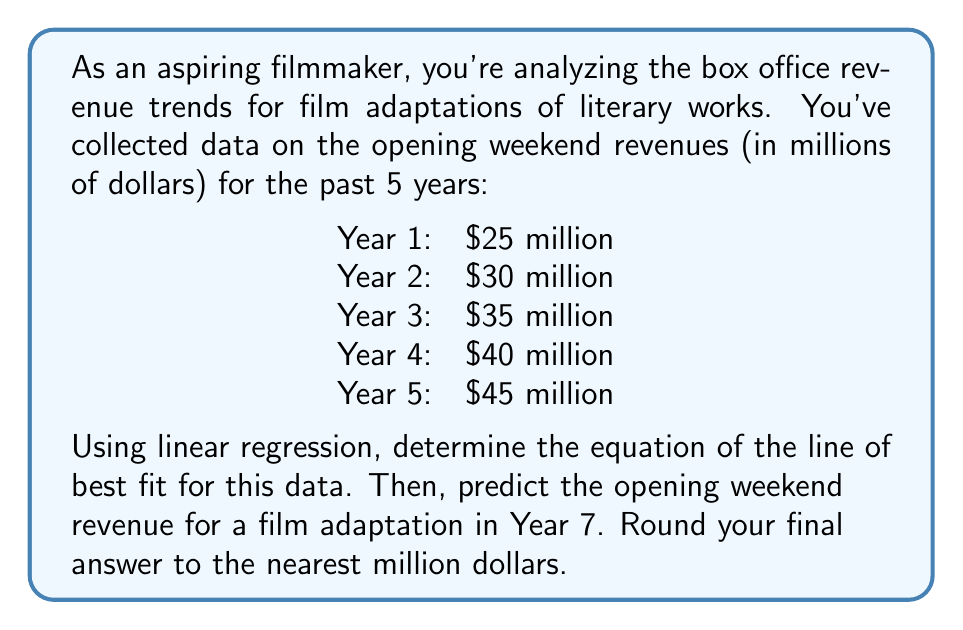Provide a solution to this math problem. Let's approach this step-by-step using linear regression:

1) First, let's set up our data points. We'll use x for the year (1-5) and y for the revenue (in millions):

   (1, 25), (2, 30), (3, 35), (4, 40), (5, 45)

2) For linear regression, we need to calculate:
   $$\bar{x} = \frac{\sum x}{n}, \bar{y} = \frac{\sum y}{n}$$
   $$m = \frac{n\sum xy - \sum x \sum y}{n\sum x^2 - (\sum x)^2}$$
   $$b = \bar{y} - m\bar{x}$$

3) Let's calculate these values:
   $$\sum x = 1 + 2 + 3 + 4 + 5 = 15$$
   $$\sum y = 25 + 30 + 35 + 40 + 45 = 175$$
   $$\sum xy = 1(25) + 2(30) + 3(35) + 4(40) + 5(45) = 525$$
   $$\sum x^2 = 1^2 + 2^2 + 3^2 + 4^2 + 5^2 = 55$$
   $$n = 5$$

4) Now we can calculate:
   $$\bar{x} = \frac{15}{5} = 3, \bar{y} = \frac{175}{5} = 35$$
   $$m = \frac{5(525) - 15(175)}{5(55) - 15^2} = \frac{2625 - 2625}{275 - 225} = \frac{0}{50} = 5$$

5) With m calculated, we can find b:
   $$b = 35 - 5(3) = 35 - 15 = 20$$

6) Our line of best fit equation is:
   $$y = 5x + 20$$

7) To predict the revenue for Year 7, we substitute x = 7:
   $$y = 5(7) + 20 = 35 + 20 = 55$$

Therefore, the predicted opening weekend revenue for Year 7 is $55 million.
Answer: $55 million 